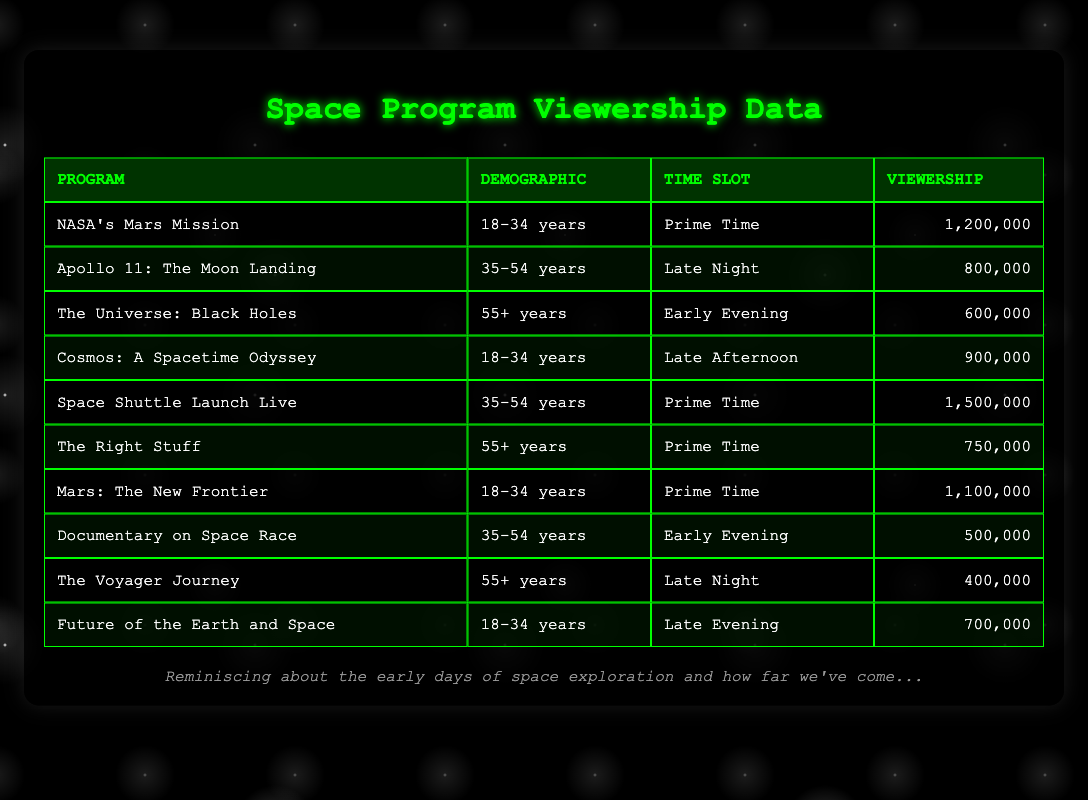What is the viewership for "NASA's Mars Mission"? The table shows that the viewership for "NASA's Mars Mission" is listed under the viewership column as 1,200,000.
Answer: 1,200,000 Which program has the highest viewership in the Prime Time slot? Scanning the Prime Time rows in the table, "Space Shuttle Launch Live" has the highest viewership at 1,500,000 compared to other Prime Time programs listed.
Answer: Space Shuttle Launch Live Is the viewership for "The Voyager Journey" more than 500,000? The viewership for "The Voyager Journey" is listed as 400,000, which is less than 500,000.
Answer: No What is the total viewership for programs targeted to the 35-54 age demographic? The table shows two programs for this demographic, "Apollo 11: The Moon Landing" with 800,000 and "Space Shuttle Launch Live" with 1,500,000. Adding them gives us a total of 800,000 + 1,500,000 = 2,300,000.
Answer: 2,300,000 What proportion of the total viewership does the "Late Evening" time slot hold? The table indicates the viewership for "Future of the Earth and Space" during the Late Evening is 700,000. The total viewership from the other programs combined is 1,200,000 + 800,000 + 600,000 + 900,000 + 1,500,000 + 750,000 + 1,100,000 + 500,000 + 400,000 = 7,050,000. The proportion is then calculated as 700,000 / 7,050,000.
Answer: Approximately 0.099 or 9.9% What demographic primarily views the program "The Right Stuff"? Checking the row for "The Right Stuff," it indicates the demographic is "55+ years."
Answer: 55+ years Which time slot has the most programs listed in the table? By reviewing the time slots for all programs, we see that the Prime Time slot has three programs: "NASA's Mars Mission," "Space Shuttle Launch Live," and "Mars: The New Frontier." Whereas other time slots have two programs or fewer.
Answer: Prime Time What is the average viewership for programs aimed at the 18-34 demographic? The table includes three programs for this group: "NASA's Mars Mission" (1,200,000), "Cosmos: A Spacetime Odyssey" (900,000), and "Mars: The New Frontier" (1,100,000). The average viewership is calculated by first summing: 1,200,000 + 900,000 + 1,100,000 = 3,200,000, then divide by the number of programs, which is 3. So, average = 3,200,000 / 3 = 1,066,666.67, rounded to 1,066,667.
Answer: 1,066,667 